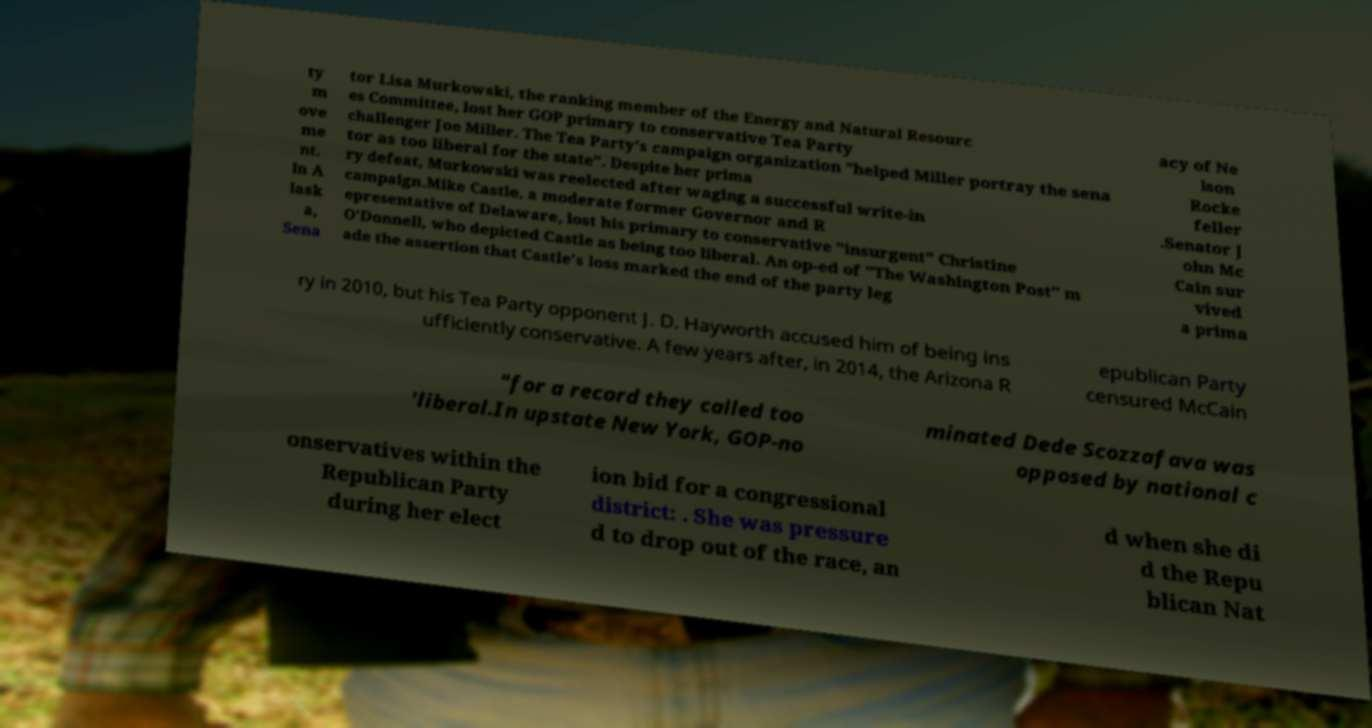Can you accurately transcribe the text from the provided image for me? ty m ove me nt. In A lask a, Sena tor Lisa Murkowski, the ranking member of the Energy and Natural Resourc es Committee, lost her GOP primary to conservative Tea Party challenger Joe Miller. The Tea Party's campaign organization "helped Miller portray the sena tor as too liberal for the state". Despite her prima ry defeat, Murkowski was reelected after waging a successful write-in campaign.Mike Castle, a moderate former Governor and R epresentative of Delaware, lost his primary to conservative "insurgent" Christine O'Donnell, who depicted Castle as being too liberal. An op-ed of "The Washington Post" m ade the assertion that Castle's loss marked the end of the party leg acy of Ne lson Rocke feller .Senator J ohn Mc Cain sur vived a prima ry in 2010, but his Tea Party opponent J. D. Hayworth accused him of being ins ufficiently conservative. A few years after, in 2014, the Arizona R epublican Party censured McCain "for a record they called too 'liberal.In upstate New York, GOP-no minated Dede Scozzafava was opposed by national c onservatives within the Republican Party during her elect ion bid for a congressional district: . She was pressure d to drop out of the race, an d when she di d the Repu blican Nat 